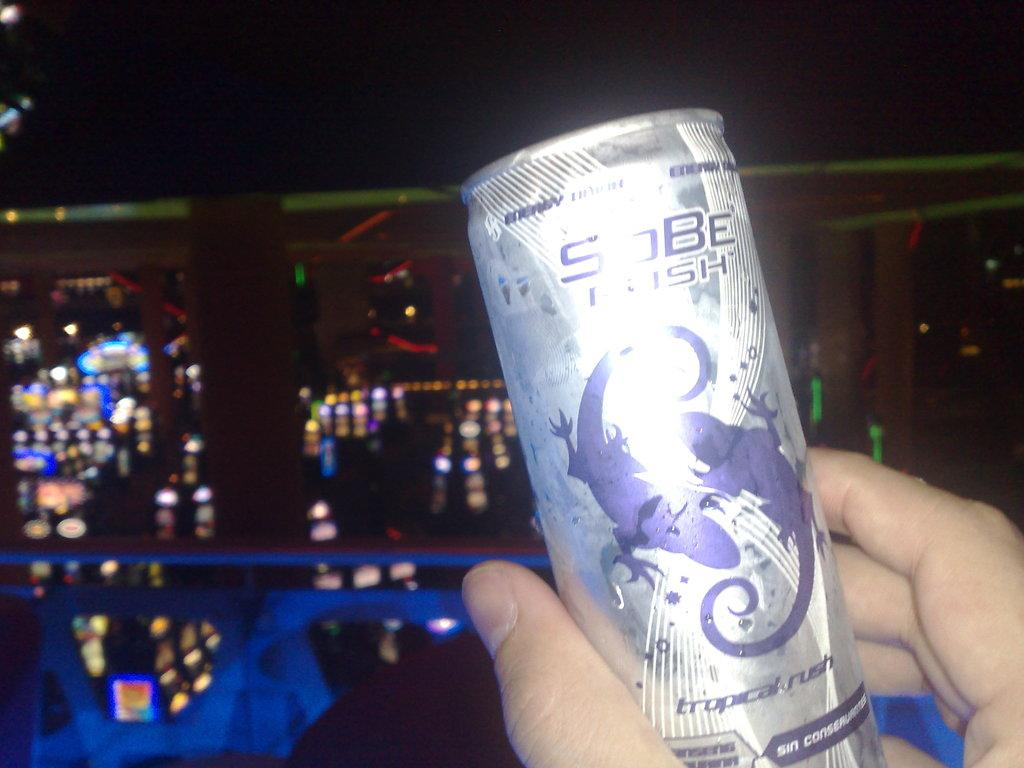<image>
Offer a succinct explanation of the picture presented. Man holding Sobe Tropical Rush in a silver can. 